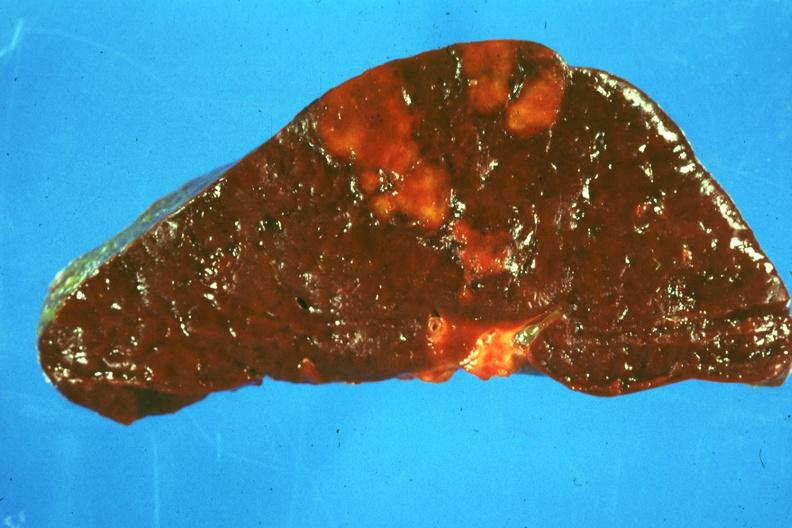what is present?
Answer the question using a single word or phrase. Infarct 